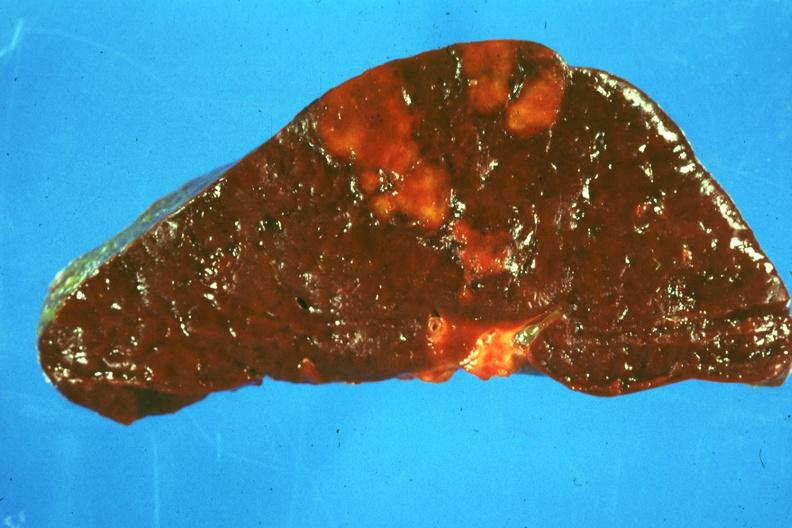what is present?
Answer the question using a single word or phrase. Infarct 